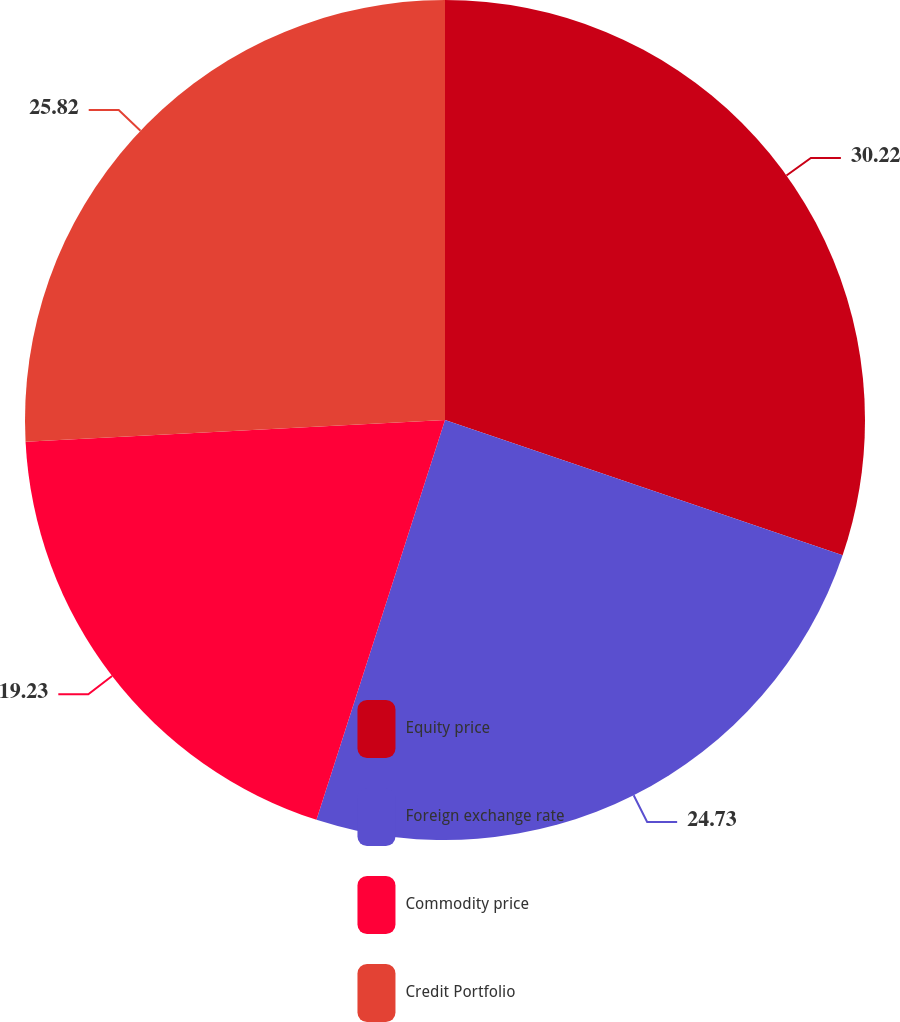Convert chart to OTSL. <chart><loc_0><loc_0><loc_500><loc_500><pie_chart><fcel>Equity price<fcel>Foreign exchange rate<fcel>Commodity price<fcel>Credit Portfolio<nl><fcel>30.22%<fcel>24.73%<fcel>19.23%<fcel>25.82%<nl></chart> 